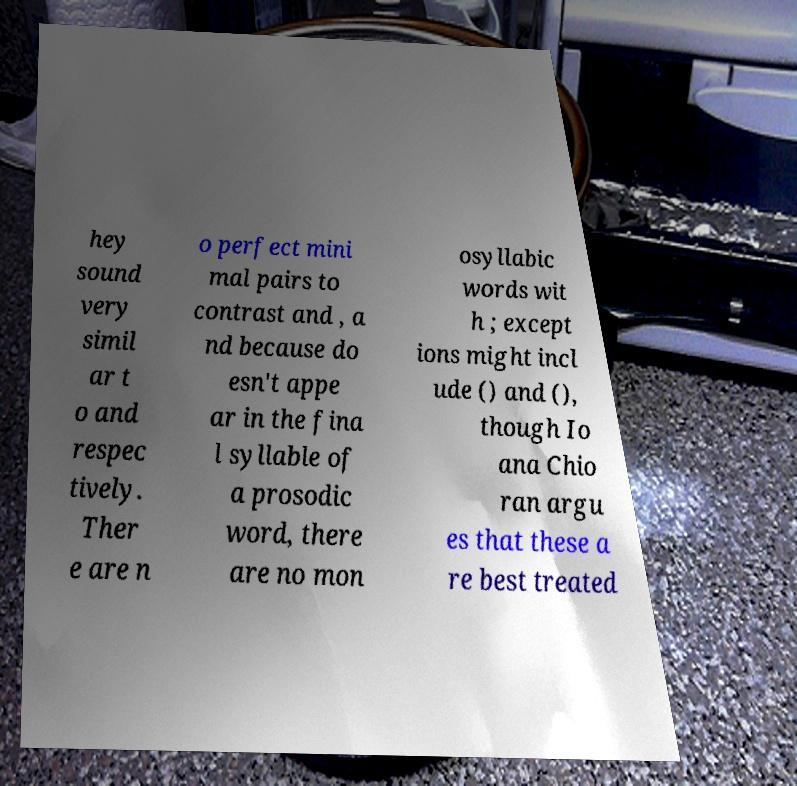Can you accurately transcribe the text from the provided image for me? hey sound very simil ar t o and respec tively. Ther e are n o perfect mini mal pairs to contrast and , a nd because do esn't appe ar in the fina l syllable of a prosodic word, there are no mon osyllabic words wit h ; except ions might incl ude () and (), though Io ana Chio ran argu es that these a re best treated 